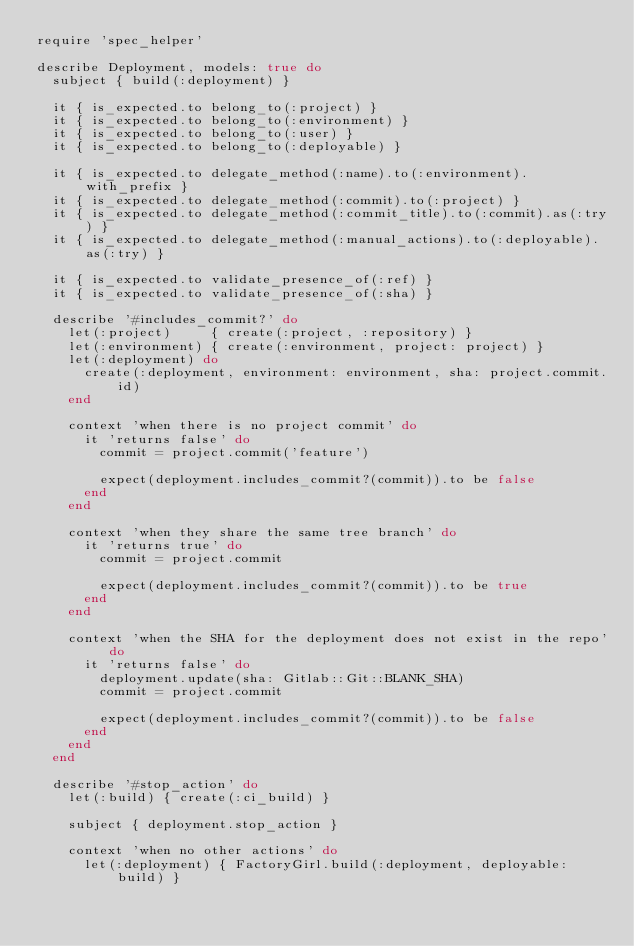<code> <loc_0><loc_0><loc_500><loc_500><_Ruby_>require 'spec_helper'

describe Deployment, models: true do
  subject { build(:deployment) }

  it { is_expected.to belong_to(:project) }
  it { is_expected.to belong_to(:environment) }
  it { is_expected.to belong_to(:user) }
  it { is_expected.to belong_to(:deployable) }

  it { is_expected.to delegate_method(:name).to(:environment).with_prefix }
  it { is_expected.to delegate_method(:commit).to(:project) }
  it { is_expected.to delegate_method(:commit_title).to(:commit).as(:try) }
  it { is_expected.to delegate_method(:manual_actions).to(:deployable).as(:try) }

  it { is_expected.to validate_presence_of(:ref) }
  it { is_expected.to validate_presence_of(:sha) }

  describe '#includes_commit?' do
    let(:project)     { create(:project, :repository) }
    let(:environment) { create(:environment, project: project) }
    let(:deployment) do
      create(:deployment, environment: environment, sha: project.commit.id)
    end

    context 'when there is no project commit' do
      it 'returns false' do
        commit = project.commit('feature')

        expect(deployment.includes_commit?(commit)).to be false
      end
    end

    context 'when they share the same tree branch' do
      it 'returns true' do
        commit = project.commit

        expect(deployment.includes_commit?(commit)).to be true
      end
    end

    context 'when the SHA for the deployment does not exist in the repo' do
      it 'returns false' do
        deployment.update(sha: Gitlab::Git::BLANK_SHA)
        commit = project.commit

        expect(deployment.includes_commit?(commit)).to be false
      end
    end
  end

  describe '#stop_action' do
    let(:build) { create(:ci_build) }

    subject { deployment.stop_action }

    context 'when no other actions' do
      let(:deployment) { FactoryGirl.build(:deployment, deployable: build) }
</code> 